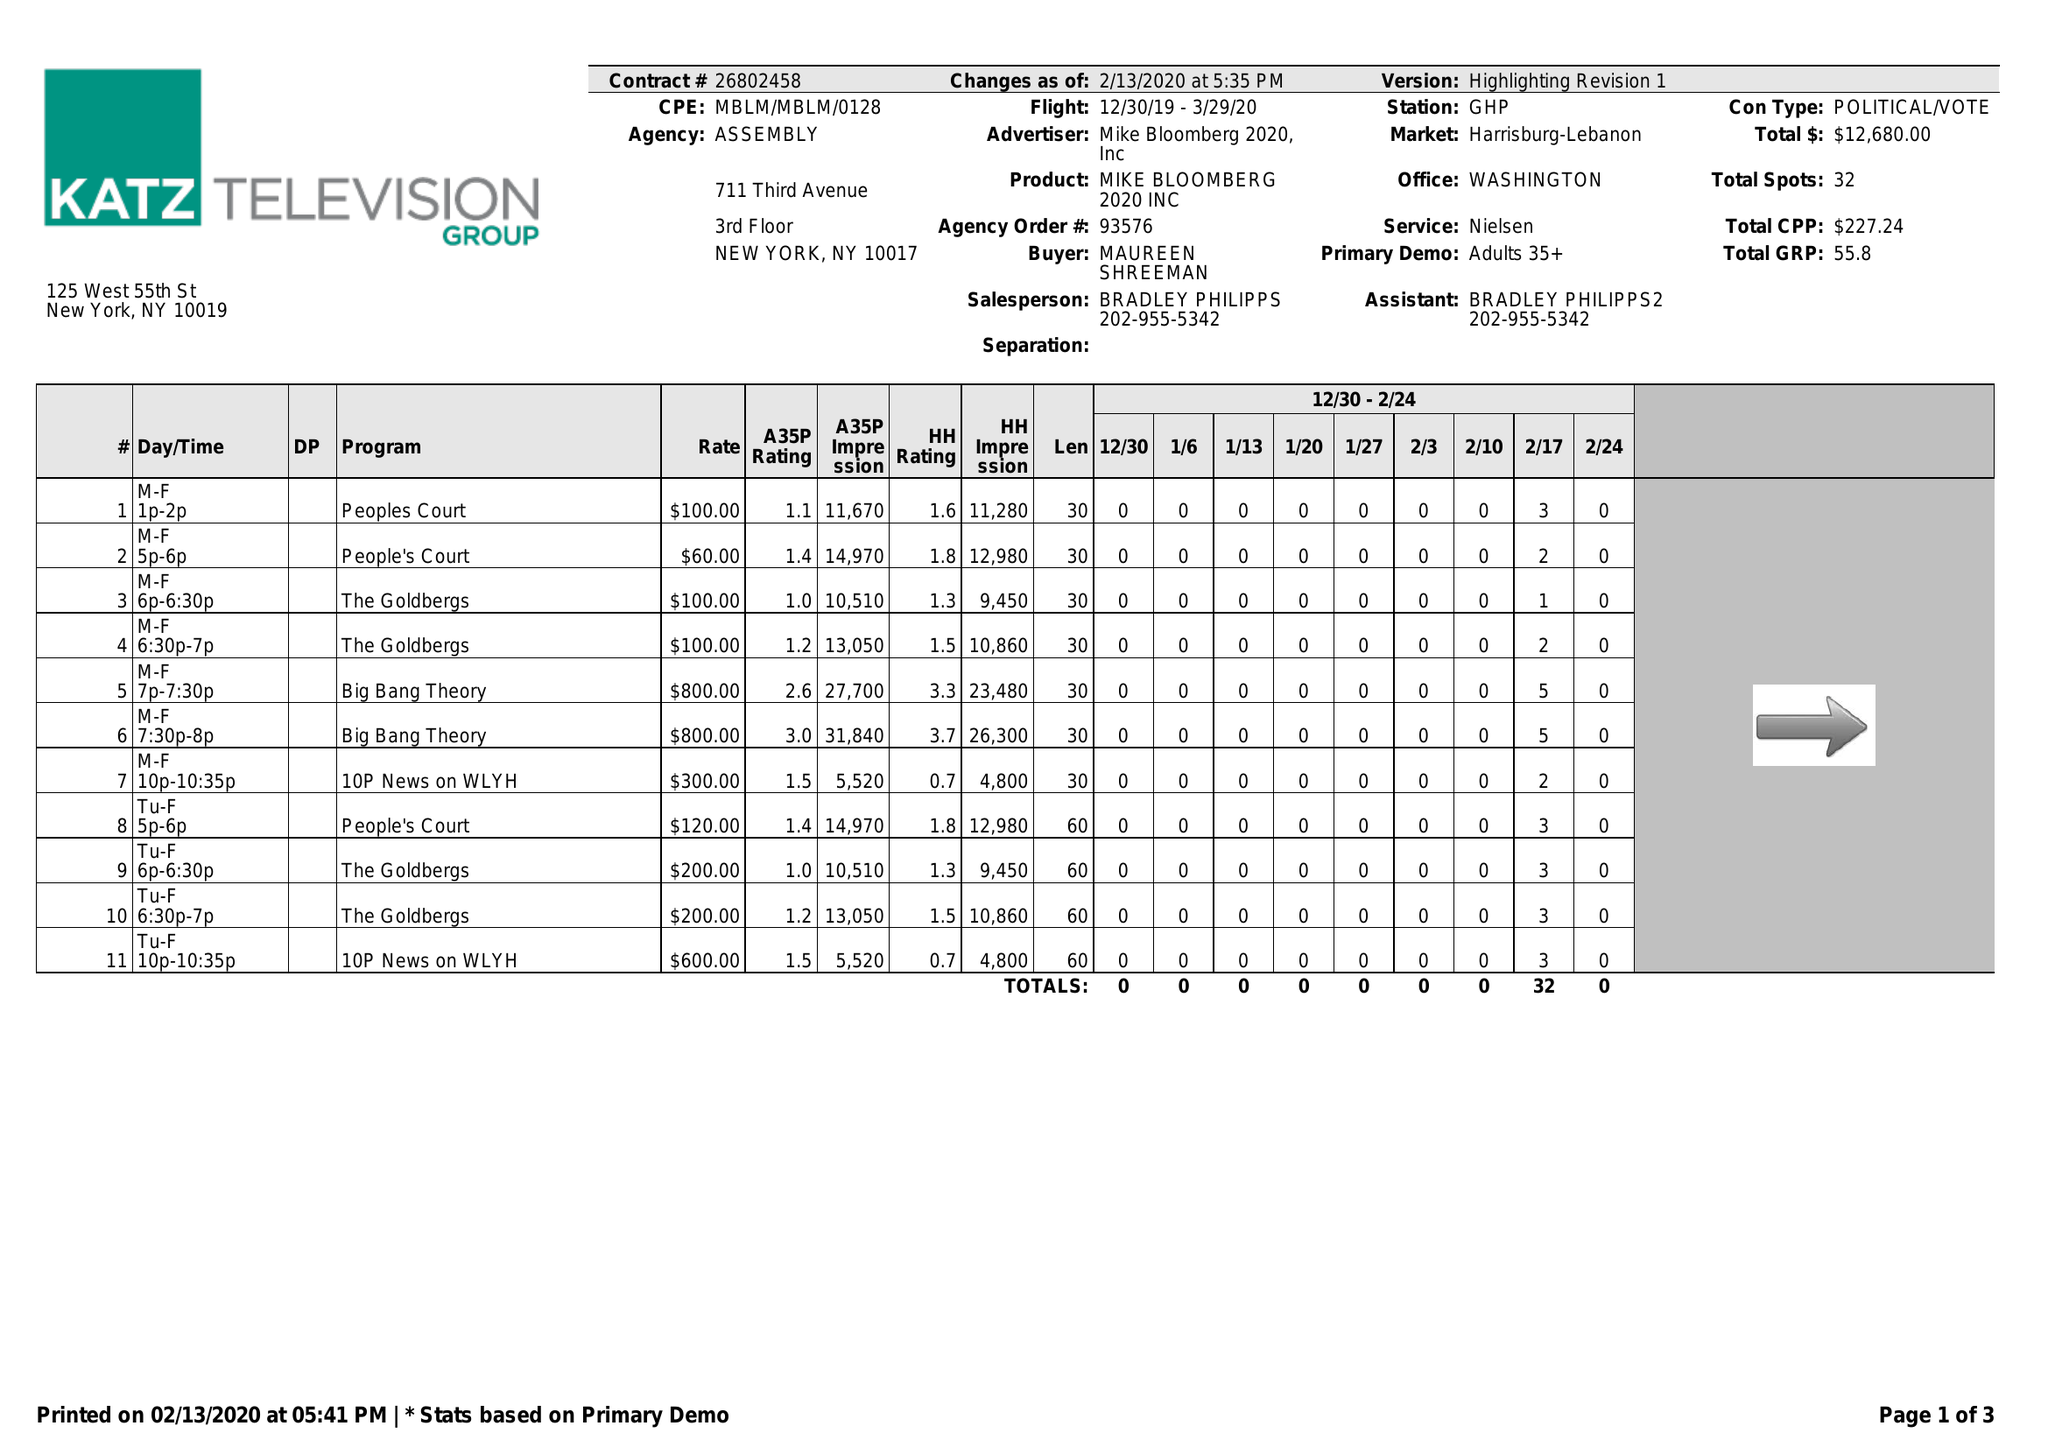What is the value for the flight_from?
Answer the question using a single word or phrase. 12/30/19 